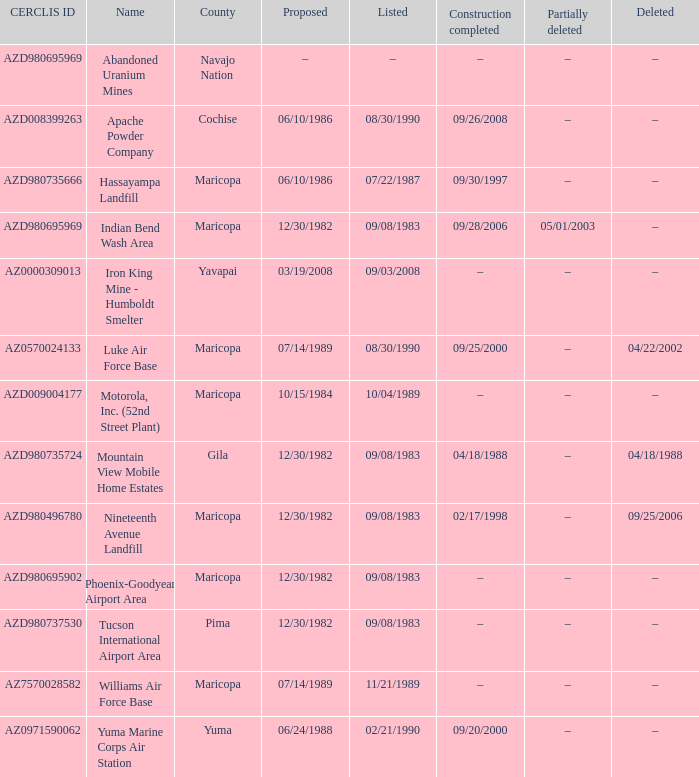When was the area documented when the county is cochise? 08/30/1990. 